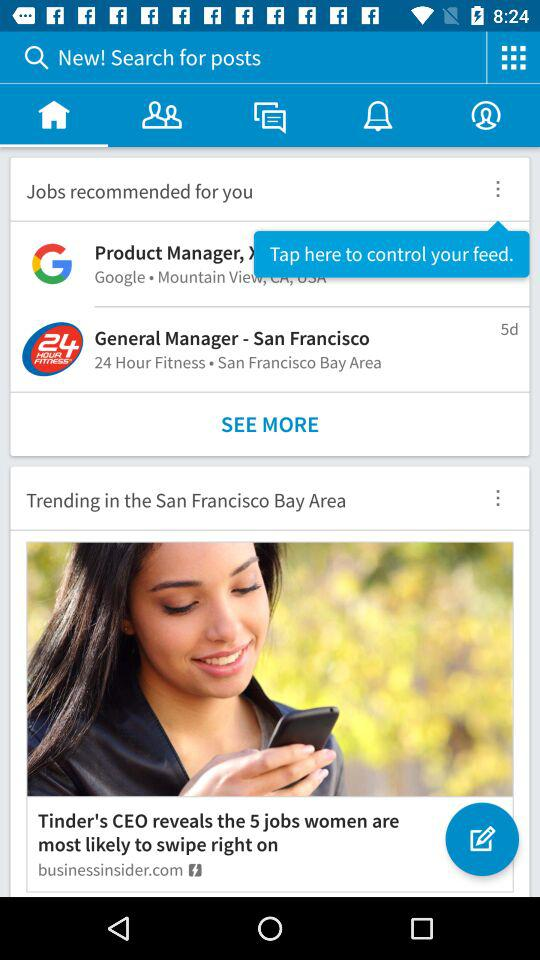How many jobs are recommended for the user?
Answer the question using a single word or phrase. 2 